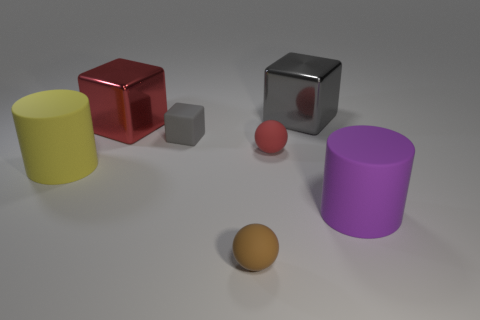There is a big matte cylinder that is to the left of the small gray rubber thing; is its color the same as the tiny rubber thing in front of the big yellow rubber object?
Ensure brevity in your answer.  No. Is the number of matte cylinders left of the red matte object less than the number of small gray objects?
Give a very brief answer. No. How many objects are either small red rubber cylinders or large metal blocks behind the red metal thing?
Give a very brief answer. 1. What color is the block that is the same material as the tiny brown object?
Your response must be concise. Gray. What number of objects are either tiny blocks or blue balls?
Make the answer very short. 1. There is a rubber cylinder that is the same size as the yellow thing; what color is it?
Your answer should be very brief. Purple. How many things are either metallic cubes that are to the left of the tiny red sphere or large gray shiny blocks?
Keep it short and to the point. 2. How many other objects are the same size as the red cube?
Offer a very short reply. 3. There is a cylinder left of the large purple matte object; how big is it?
Provide a succinct answer. Large. What shape is the purple object that is the same material as the tiny red thing?
Offer a very short reply. Cylinder. 